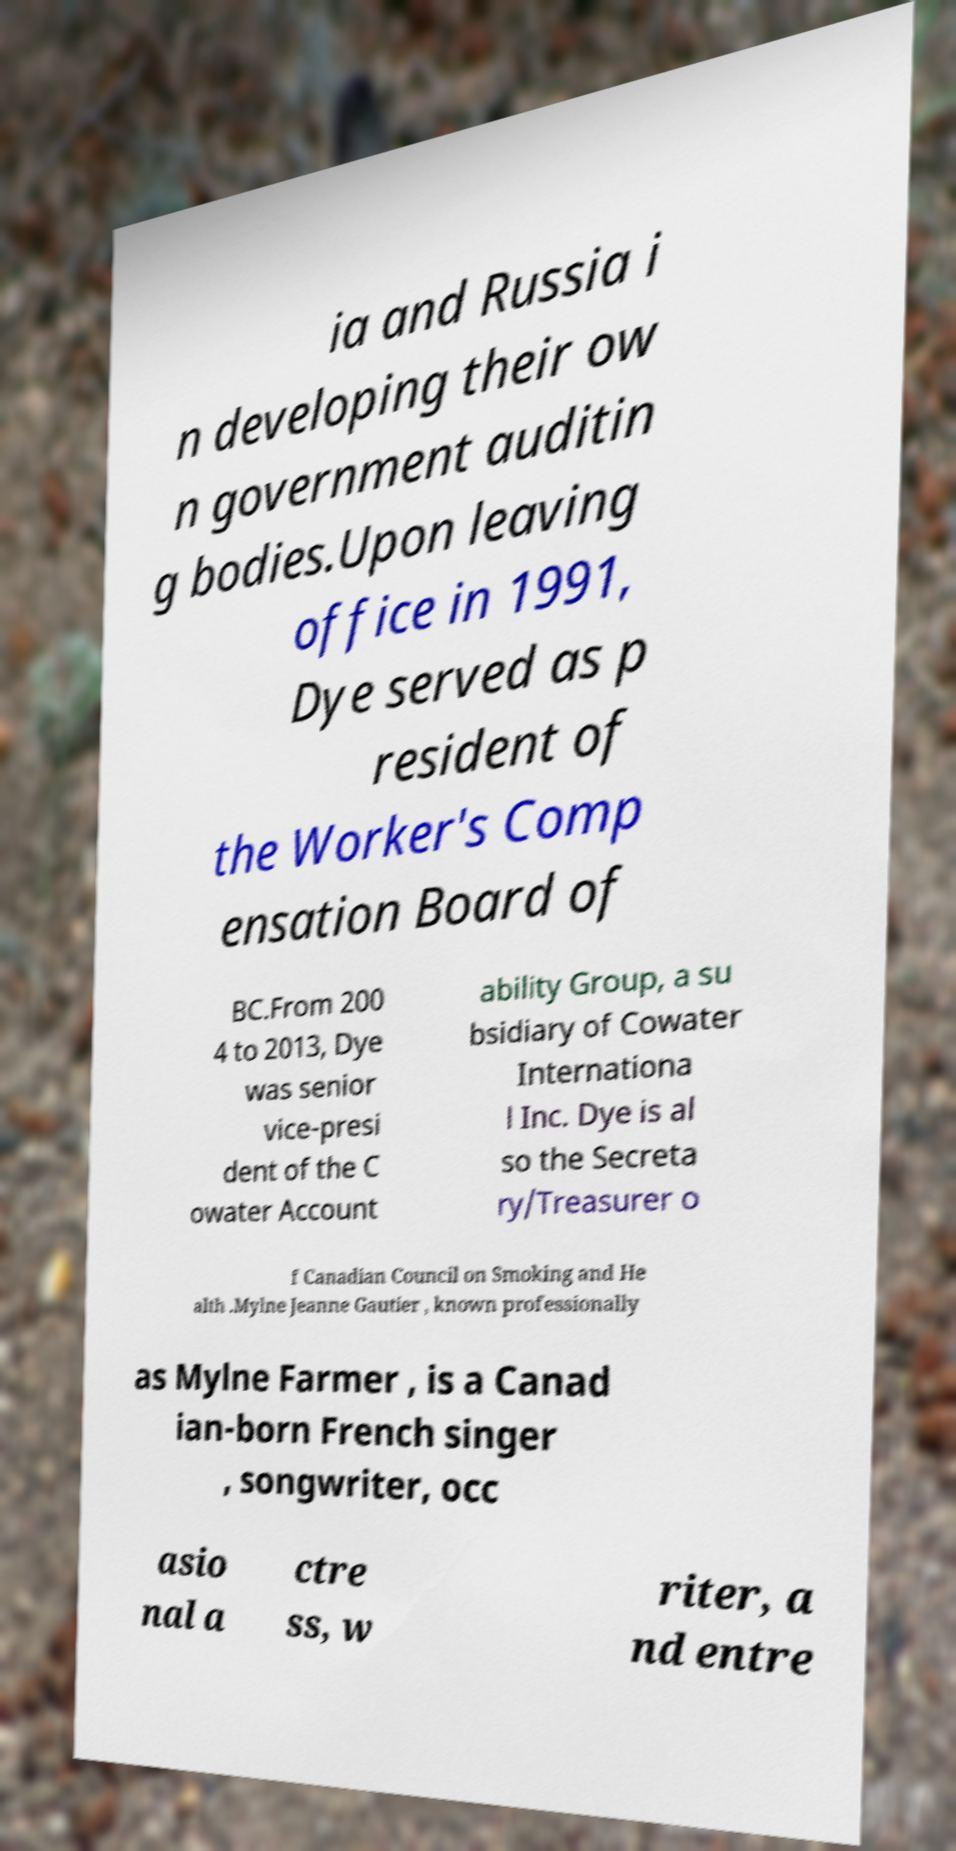I need the written content from this picture converted into text. Can you do that? ia and Russia i n developing their ow n government auditin g bodies.Upon leaving office in 1991, Dye served as p resident of the Worker's Comp ensation Board of BC.From 200 4 to 2013, Dye was senior vice-presi dent of the C owater Account ability Group, a su bsidiary of Cowater Internationa l Inc. Dye is al so the Secreta ry/Treasurer o f Canadian Council on Smoking and He alth .Mylne Jeanne Gautier , known professionally as Mylne Farmer , is a Canad ian-born French singer , songwriter, occ asio nal a ctre ss, w riter, a nd entre 